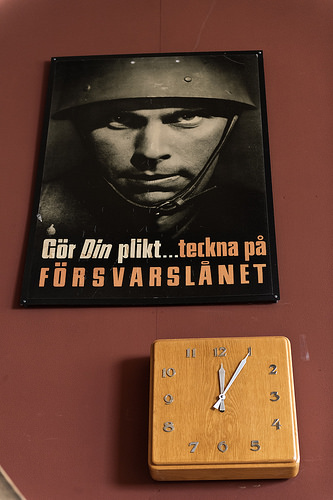<image>
Can you confirm if the poster is on the clock? No. The poster is not positioned on the clock. They may be near each other, but the poster is not supported by or resting on top of the clock. 